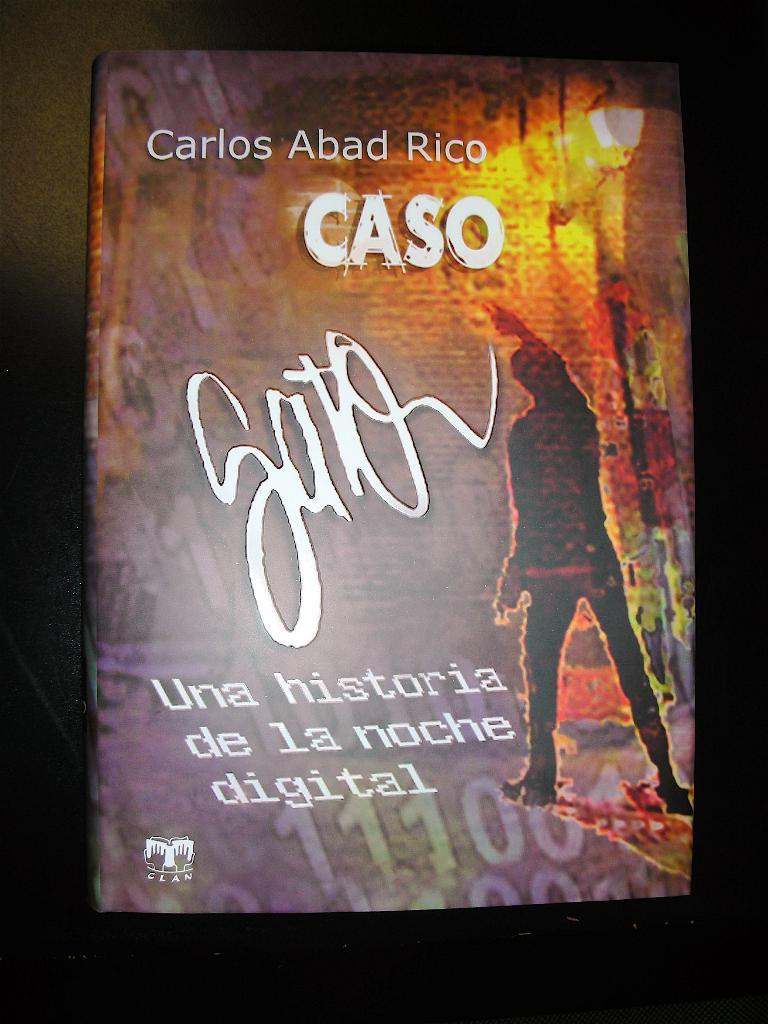Provide a one-sentence caption for the provided image. A Spanish language poster which mentions Carlos Abad Rico CASO, hangs on a dark wall. 